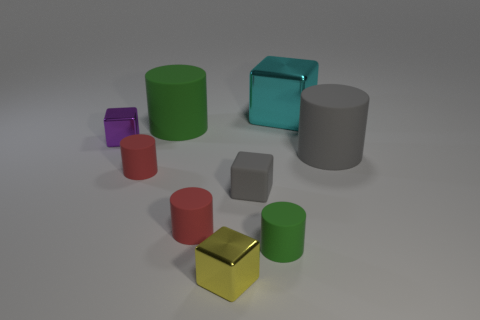Subtract all large cylinders. How many cylinders are left? 3 Subtract 2 cylinders. How many cylinders are left? 3 Subtract all gray cylinders. How many cylinders are left? 4 Add 1 large cylinders. How many objects exist? 10 Subtract all cyan cylinders. Subtract all red balls. How many cylinders are left? 5 Subtract all cylinders. How many objects are left? 4 Subtract all green spheres. Subtract all small green cylinders. How many objects are left? 8 Add 2 large cyan objects. How many large cyan objects are left? 3 Add 3 tiny metallic things. How many tiny metallic things exist? 5 Subtract 0 red balls. How many objects are left? 9 